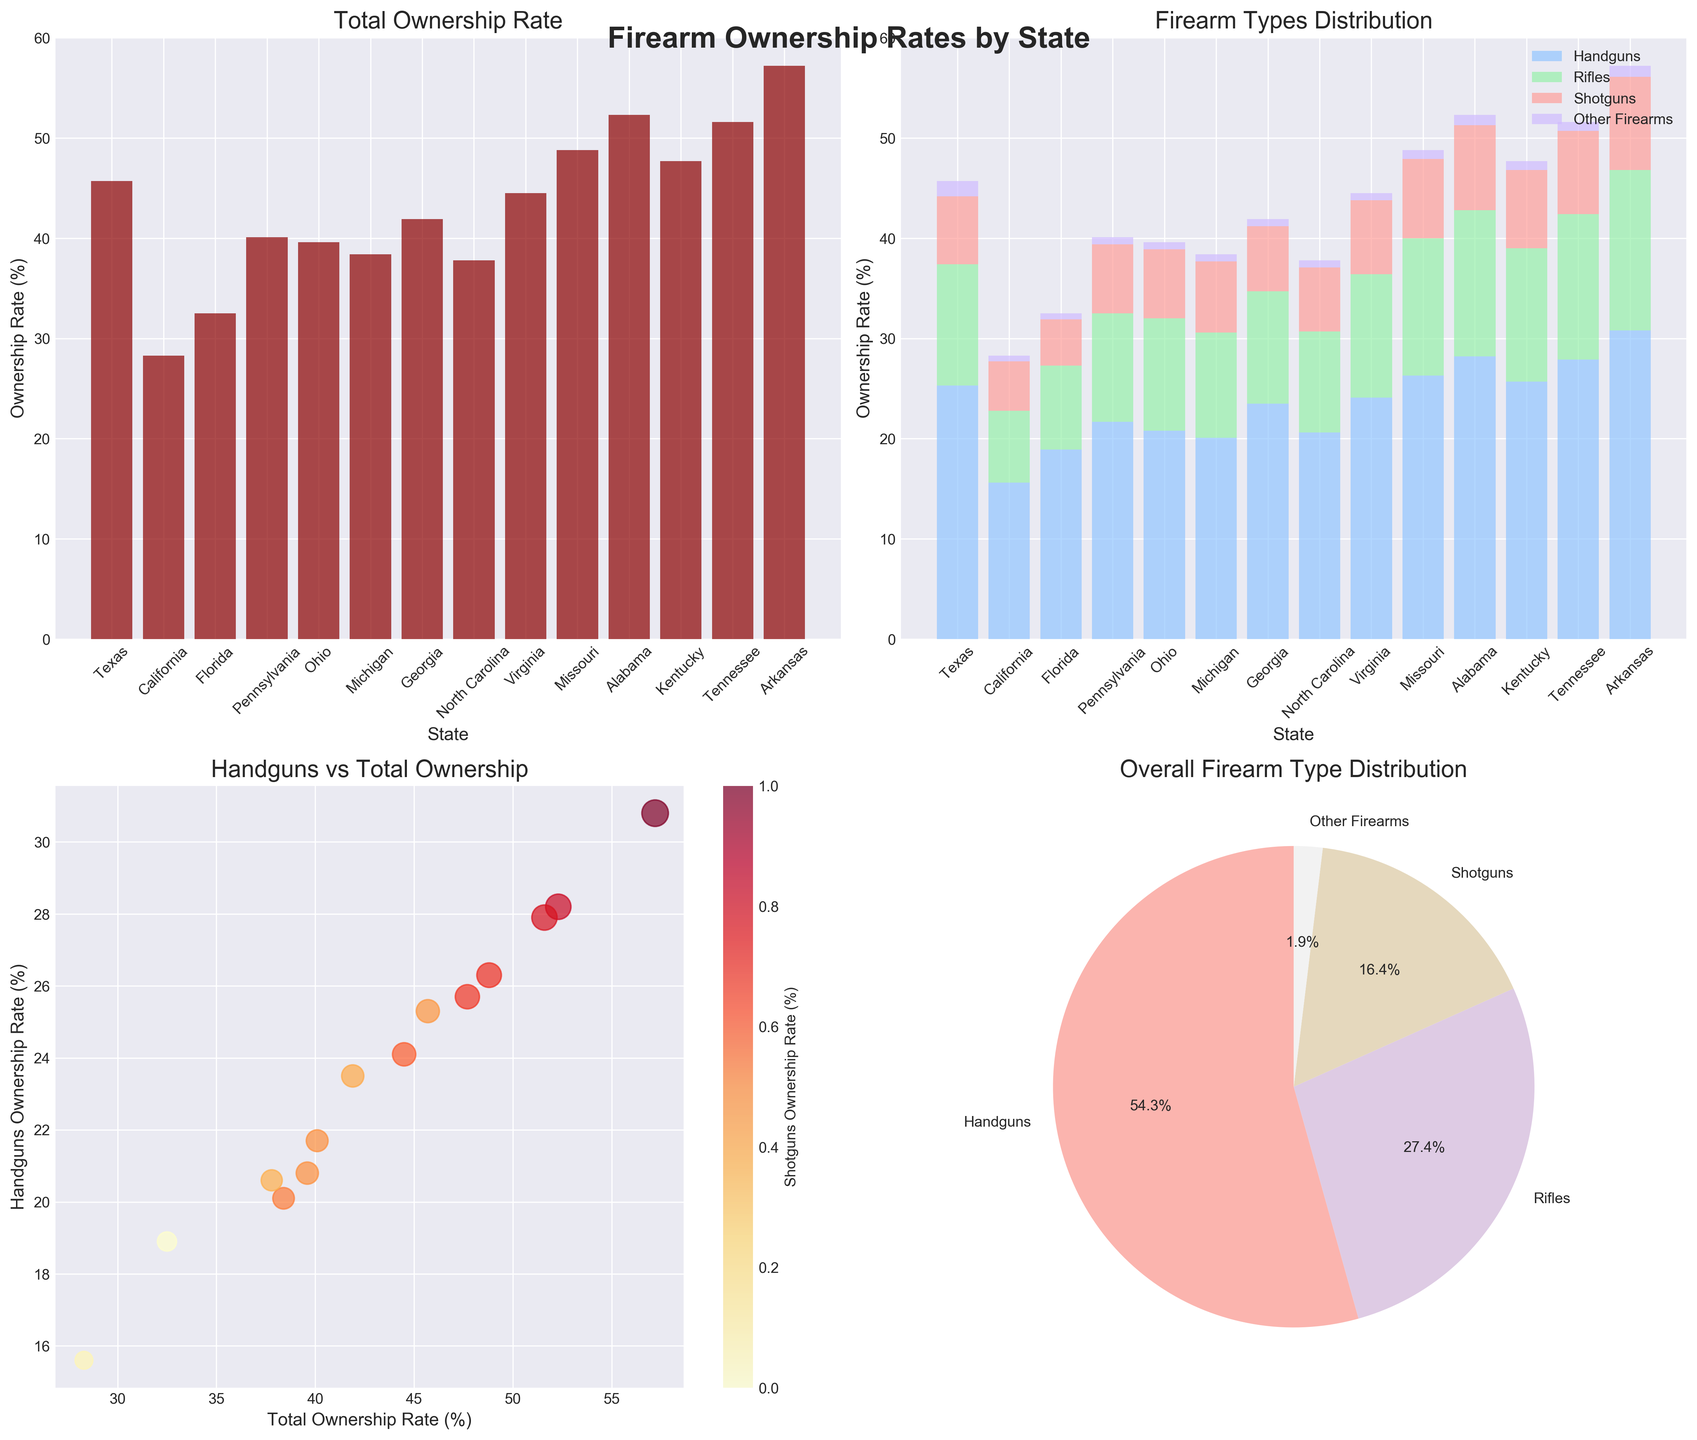What's the highest firearm ownership rate by state? To find the highest ownership rate, look at the bar plot 'Total Ownership Rate' and identify the tallest bar, which corresponds to Alabama with 52.3%.
Answer: 52.3% Which state has the largest proportion of handguns in its total ownership rate? Look at the stacked bar plot 'Firearm Types Distribution' and focus on the bottom segment of the bars (Handguns). The largest bottom segment belongs to Arkansas.
Answer: Arkansas What is the average ownership rate for shotguns across all states? From the data: Texas (6.8), California (4.9), Florida (4.6), Pennsylvania (6.9), Ohio (6.9), Michigan (7.1), Georgia (6.5), North Carolina (6.4), Virginia (7.4), Missouri (7.9), Alabama (8.5), Kentucky (7.8), Tennessee (8.3), Arkansas (9.3). Add these and divide by 14 to find the average: (6.8+4.9+4.6+6.9+6.9+7.1+6.5+6.4+7.4+7.9+8.5+7.8+8.3+9.3)/14 = 7.06.
Answer: 7.06 Which states have a total ownership rate higher than 50%? Look at the bar plot 'Total Ownership Rate' and identify the bars that exceed the 50% mark. These states are Alabama, Tennessee, and Arkansas.
Answer: Alabama, Tennessee, Arkansas How does the proportion of rifles compare between Texas and Missouri? From the stacked bar plot, compare the third segment from the bottom in both Texas and Missouri. Texas has a rifle ownership rate of 12.1%, while Missouri has 13.7%. Therefore, Missouri has a higher proportion.
Answer: Missouri What does the size of the points in the scatter plot represent? In the scatter plot 'Handguns vs Total Ownership', the size of the points represents the rifle ownership rate. This is visibly larger in states with larger rifle ownership rates.
Answer: Rifle ownership rate What’s the dominant firearm type in the overall distribution? Look at the pie chart 'Overall Firearm Type Distribution'. The largest slice is for Handguns, which is the dominant type.
Answer: Handguns Is there a correlation between handgun ownership rates and total ownership rates? In the scatter plot 'Handguns vs Total Ownership', observe the trend of data points. A positive slope indicates a positive correlation, meaning states with higher total ownership rates also have higher handgun ownership rates.
Answer: Positive correlation Which state has the smallest ownership rate for other firearms, and what is that rate? Refer to the stacked bar plot and look for the smallest top segment (Other Firearms). California has the smallest rate at 0.6%.
Answer: California, 0.6% 